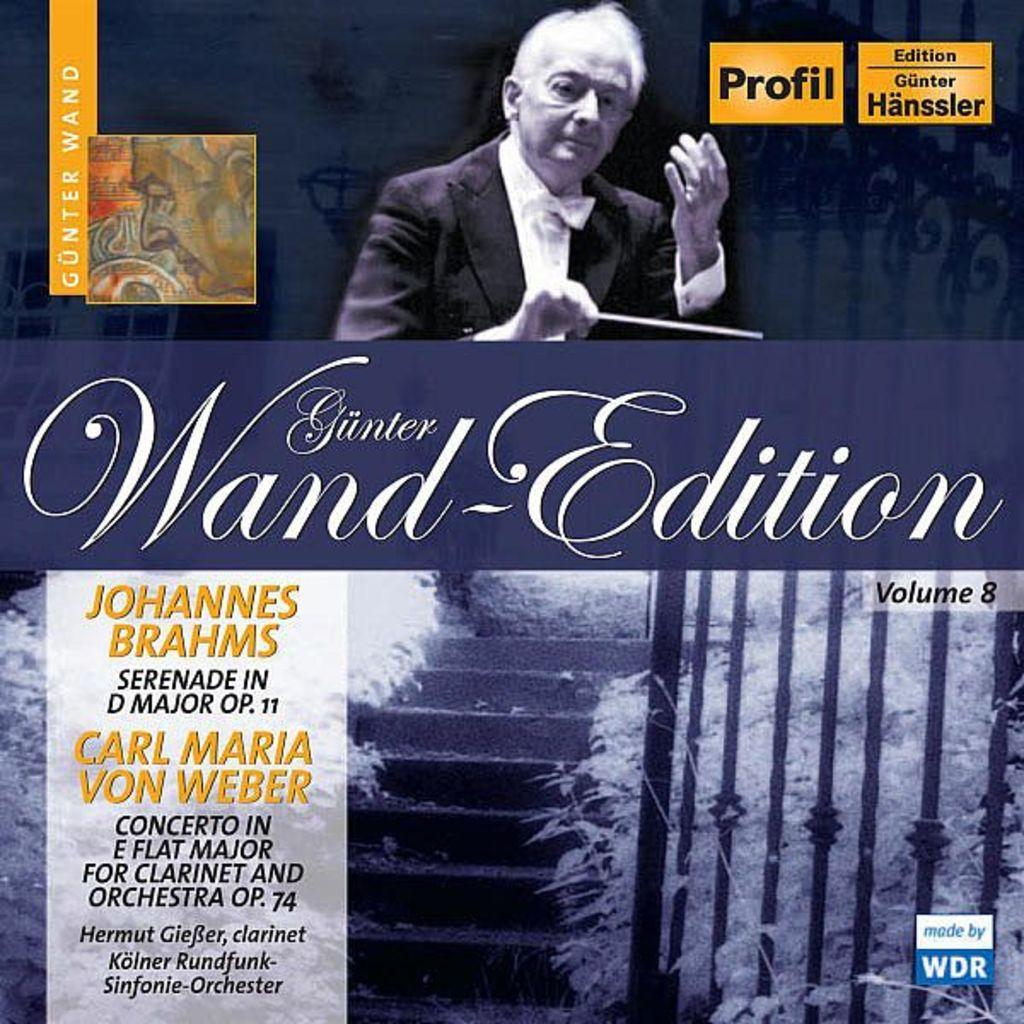Provide a one-sentence caption for the provided image. A classical music recording featuring both a Brahms and a Carl Maria von Weber piece. 